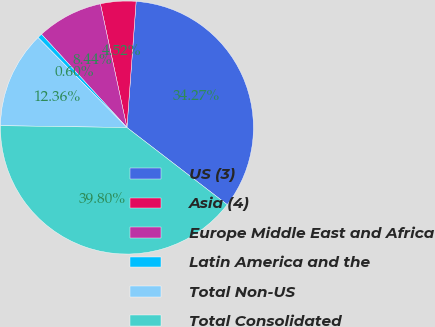<chart> <loc_0><loc_0><loc_500><loc_500><pie_chart><fcel>US (3)<fcel>Asia (4)<fcel>Europe Middle East and Africa<fcel>Latin America and the<fcel>Total Non-US<fcel>Total Consolidated<nl><fcel>34.27%<fcel>4.52%<fcel>8.44%<fcel>0.6%<fcel>12.36%<fcel>39.8%<nl></chart> 